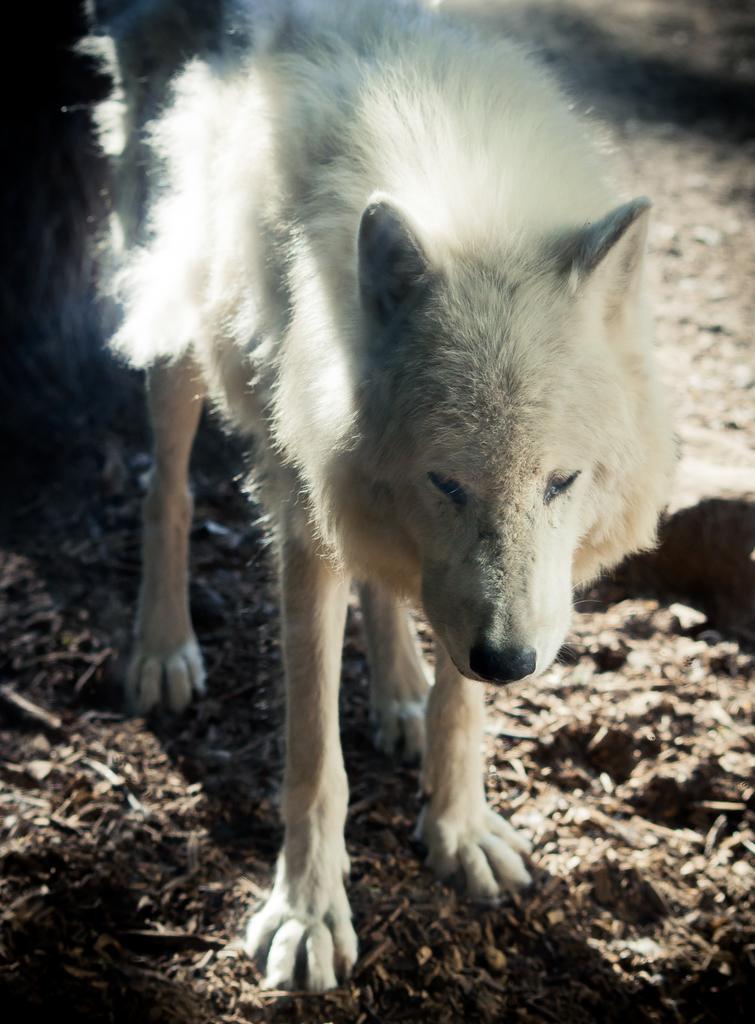Describe this image in one or two sentences. In this picture there is a wolf dog. At the bottom it is soil. 